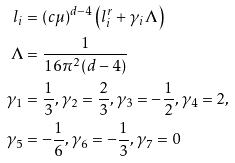Convert formula to latex. <formula><loc_0><loc_0><loc_500><loc_500>l _ { i } & = ( c \mu ) ^ { d - 4 } \left ( l _ { i } ^ { r } + \gamma _ { i } \Lambda \right ) \\ \Lambda & = \frac { 1 } { 1 6 \pi ^ { 2 } ( d - 4 ) } \\ \gamma _ { 1 } & = \frac { 1 } { 3 } , \gamma _ { 2 } = \frac { 2 } { 3 } , \gamma _ { 3 } = - \frac { 1 } { 2 } , \gamma _ { 4 } = 2 , \\ \gamma _ { 5 } & = - \frac { 1 } { 6 } , \gamma _ { 6 } = - \frac { 1 } { 3 } , \gamma _ { 7 } = 0</formula> 